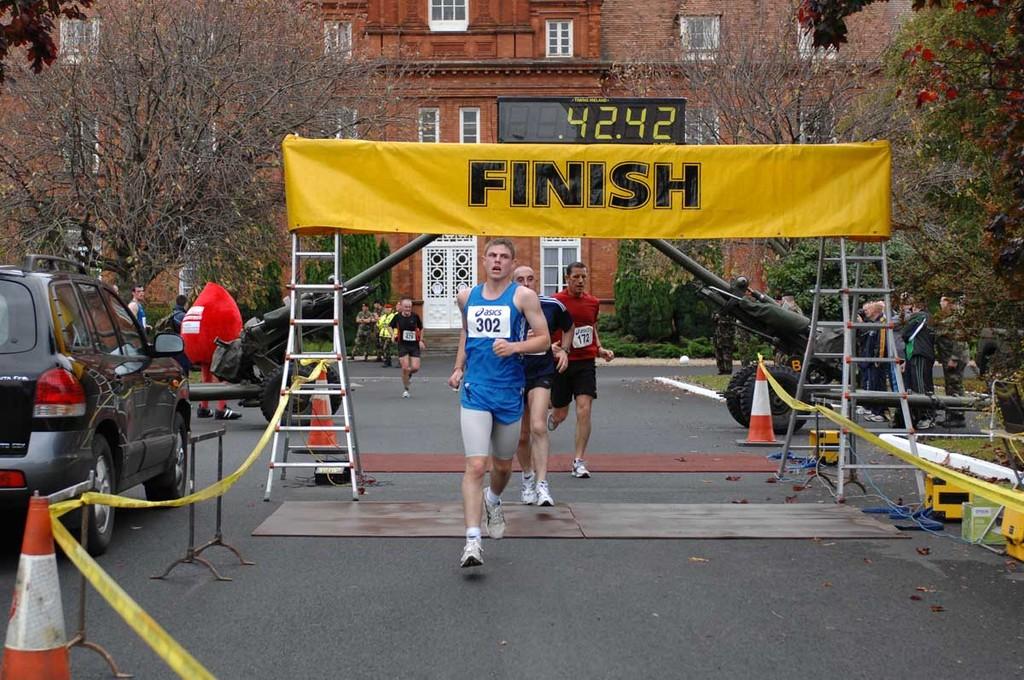What line are they crossing?
Your response must be concise. Finish. What is this runner's time?
Give a very brief answer. 42.42. 